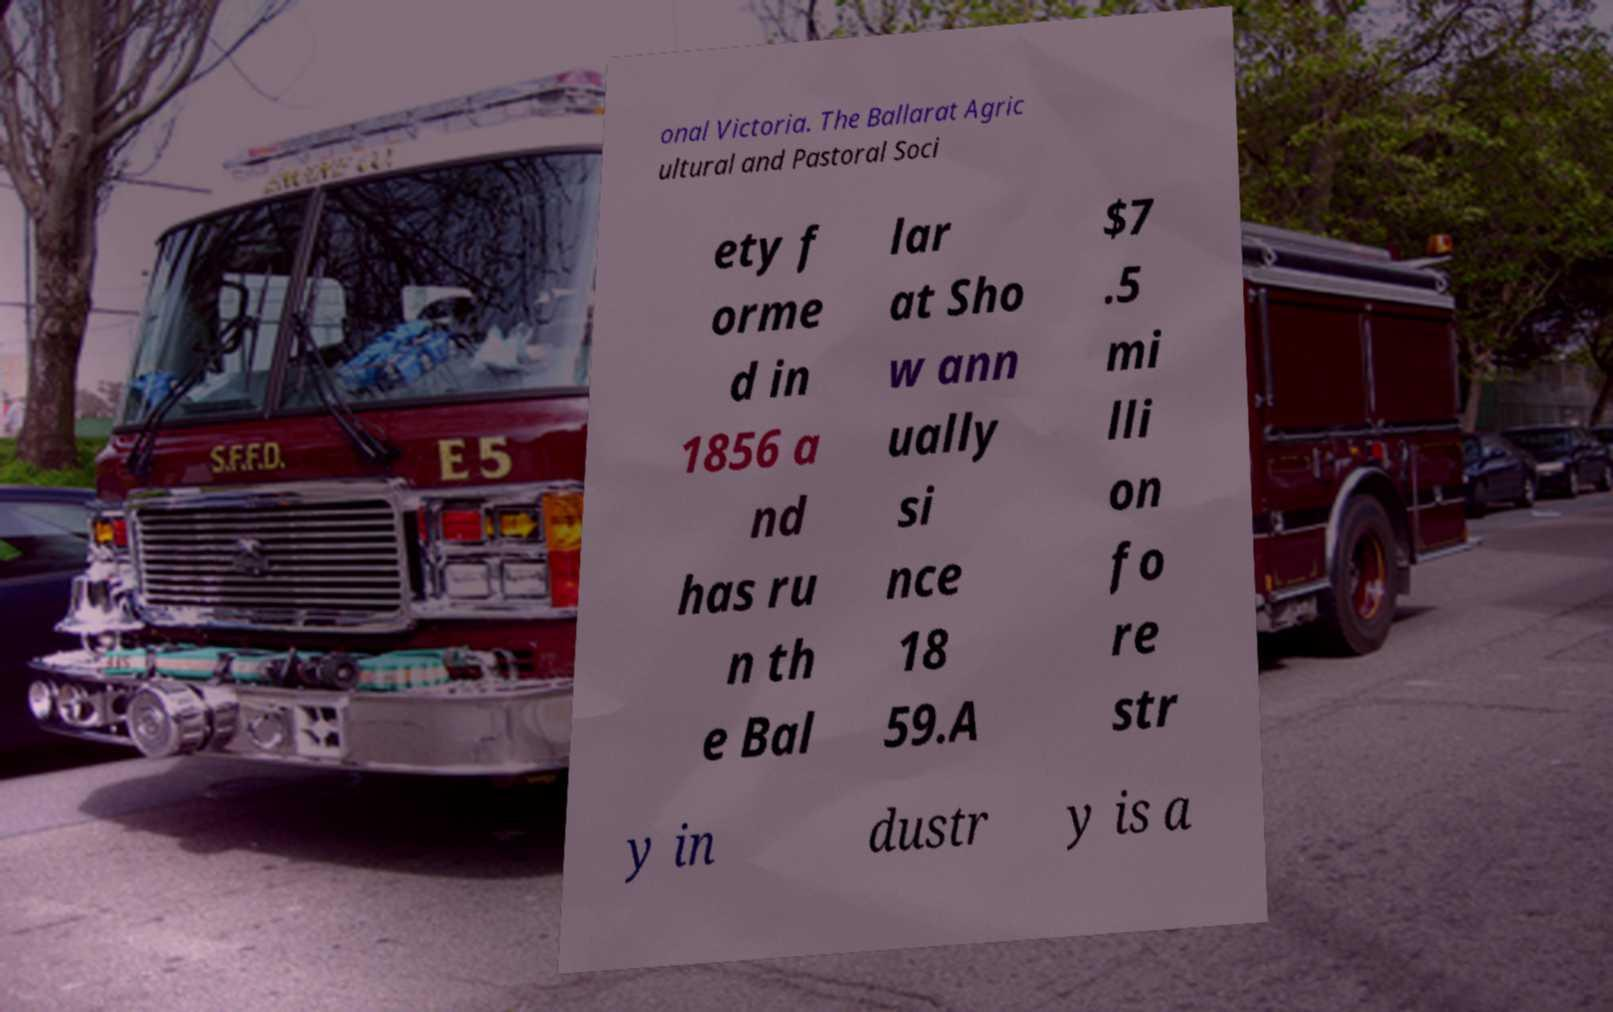Can you read and provide the text displayed in the image?This photo seems to have some interesting text. Can you extract and type it out for me? onal Victoria. The Ballarat Agric ultural and Pastoral Soci ety f orme d in 1856 a nd has ru n th e Bal lar at Sho w ann ually si nce 18 59.A $7 .5 mi lli on fo re str y in dustr y is a 